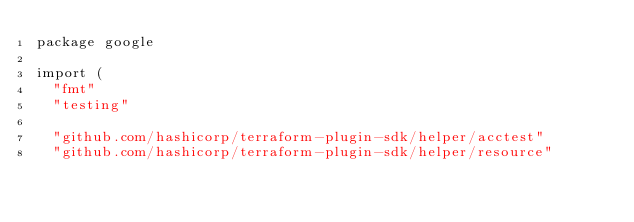<code> <loc_0><loc_0><loc_500><loc_500><_Go_>package google

import (
	"fmt"
	"testing"

	"github.com/hashicorp/terraform-plugin-sdk/helper/acctest"
	"github.com/hashicorp/terraform-plugin-sdk/helper/resource"</code> 